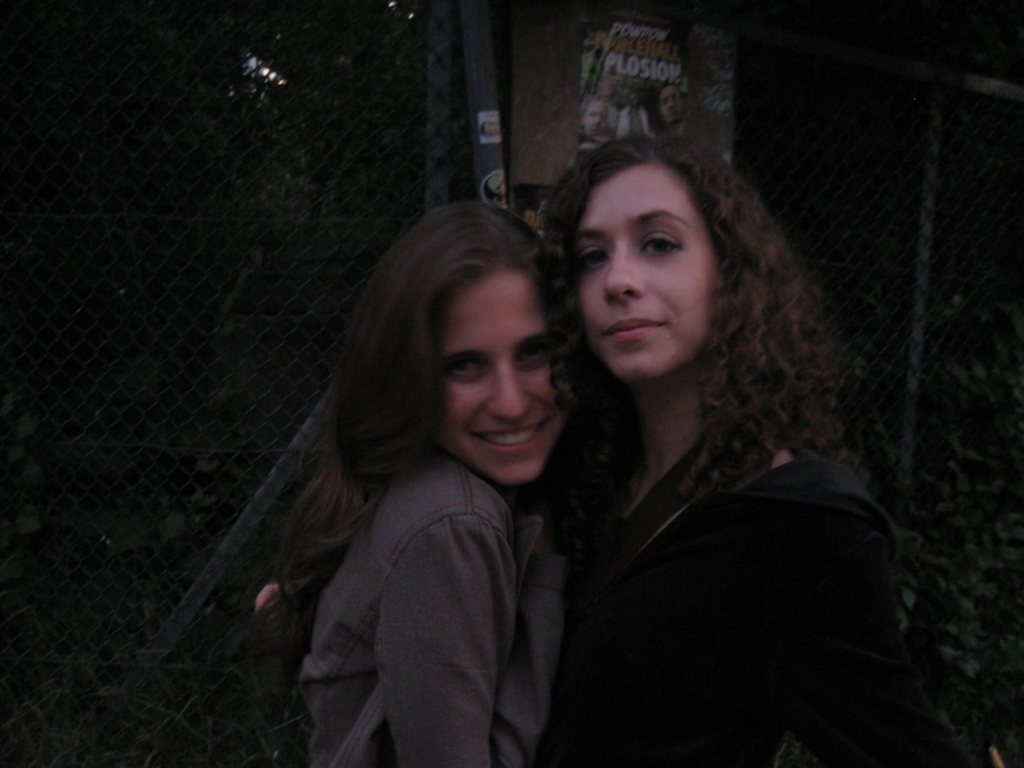What can you infer about the relationship between the two individuals? Based on their body language and the way they are leaning into each other with contented expressions, it's reasonable to infer a strong bond between the two individuals, possibly suggesting they are good friends or relatives. 